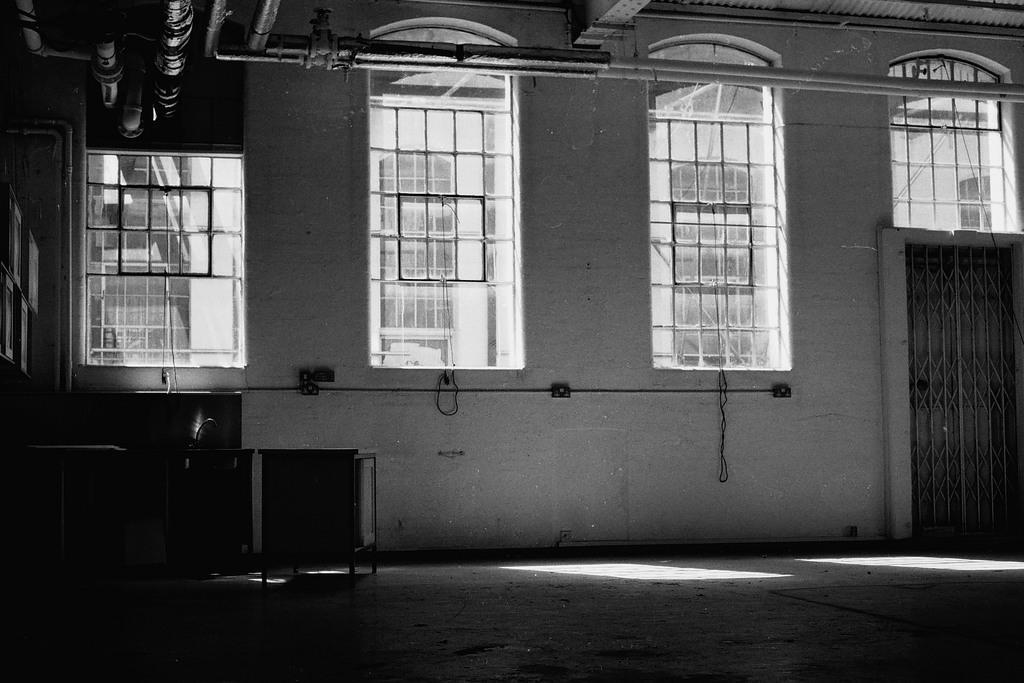In one or two sentences, can you explain what this image depicts? This image is taken indoors. This image is a black and white image. At the bottom of the image there is a floor. In the middle of the image there is a wall with windows, a door and grills. At the top of the image there is a roof. There are few pipelines. On the left side of the image there are two tables. 